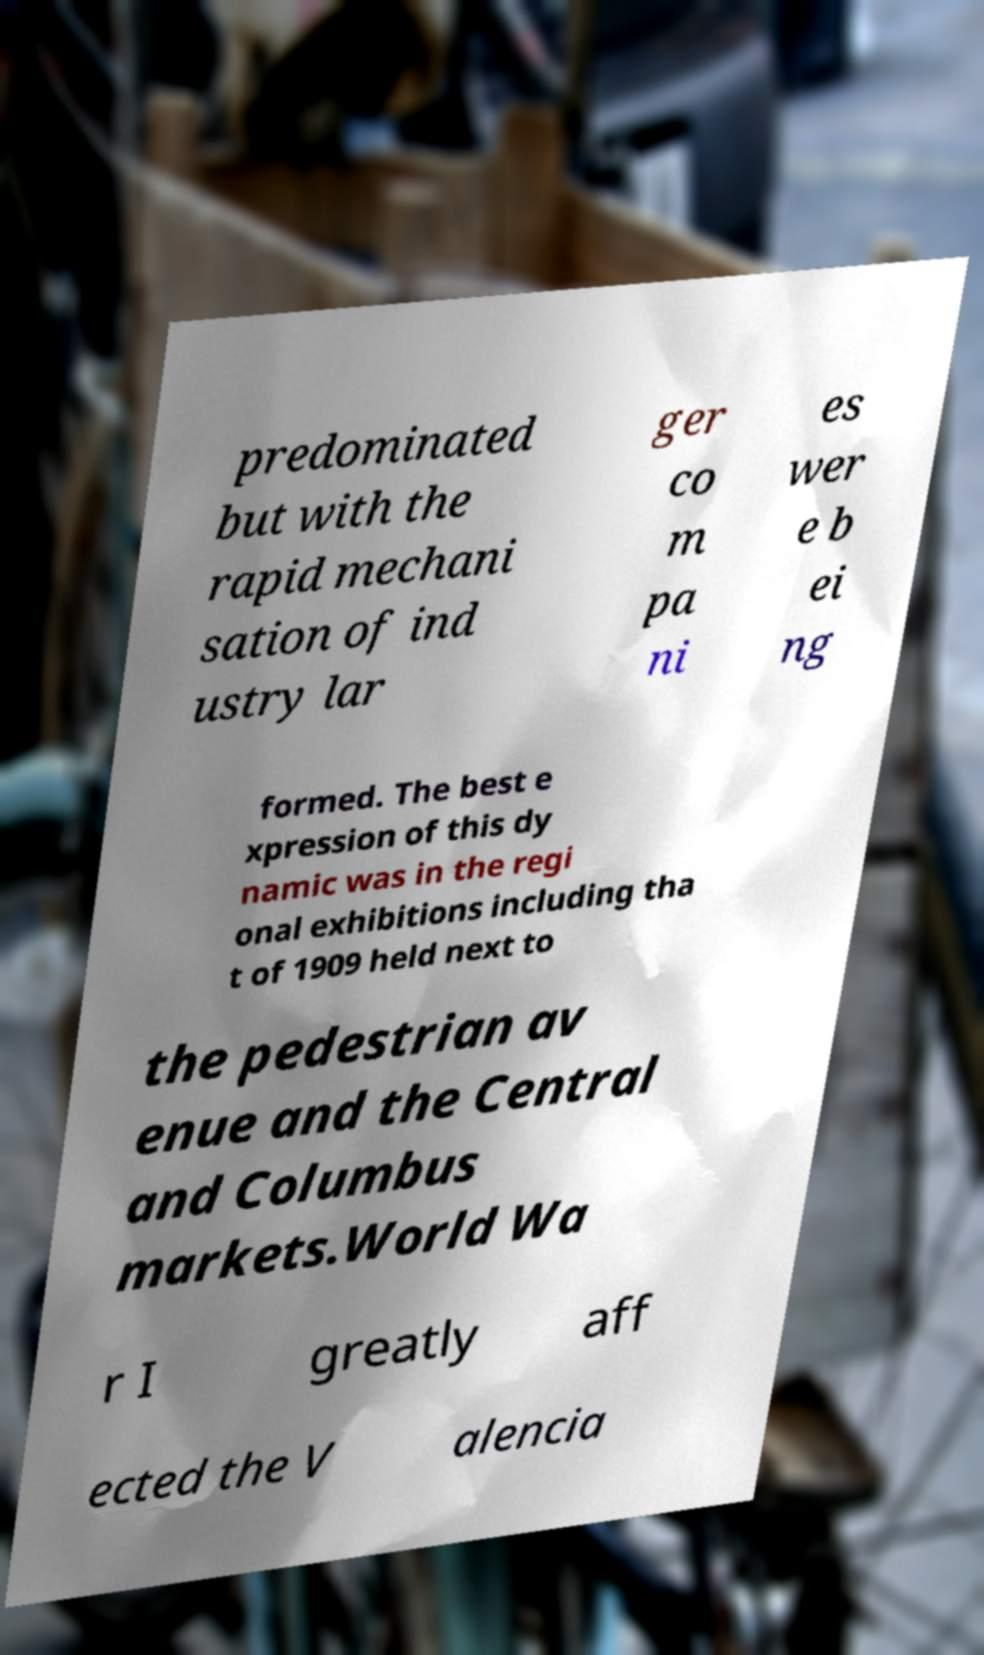Could you assist in decoding the text presented in this image and type it out clearly? predominated but with the rapid mechani sation of ind ustry lar ger co m pa ni es wer e b ei ng formed. The best e xpression of this dy namic was in the regi onal exhibitions including tha t of 1909 held next to the pedestrian av enue and the Central and Columbus markets.World Wa r I greatly aff ected the V alencia 